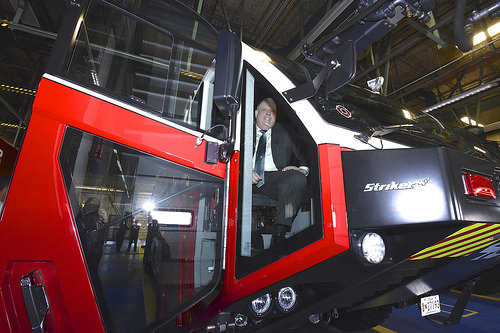<image>
Is the man on the door? No. The man is not positioned on the door. They may be near each other, but the man is not supported by or resting on top of the door. 